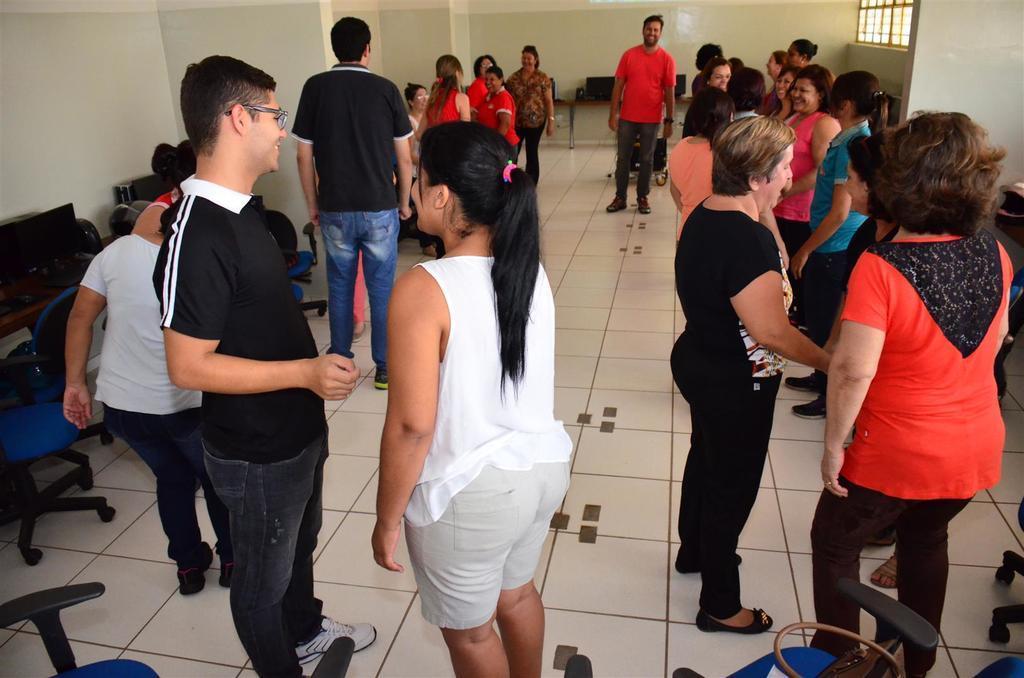Please provide a concise description of this image. In this image we can see a few people standing in the room, there are some, tables, systems, chairs and other objects, also we can see a window and the wall. 